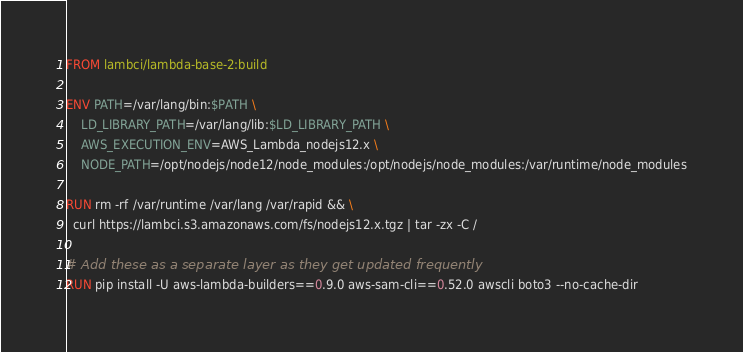Convert code to text. <code><loc_0><loc_0><loc_500><loc_500><_Dockerfile_>FROM lambci/lambda-base-2:build

ENV PATH=/var/lang/bin:$PATH \
    LD_LIBRARY_PATH=/var/lang/lib:$LD_LIBRARY_PATH \
    AWS_EXECUTION_ENV=AWS_Lambda_nodejs12.x \
    NODE_PATH=/opt/nodejs/node12/node_modules:/opt/nodejs/node_modules:/var/runtime/node_modules

RUN rm -rf /var/runtime /var/lang /var/rapid && \
  curl https://lambci.s3.amazonaws.com/fs/nodejs12.x.tgz | tar -zx -C /

# Add these as a separate layer as they get updated frequently
RUN pip install -U aws-lambda-builders==0.9.0 aws-sam-cli==0.52.0 awscli boto3 --no-cache-dir
</code> 